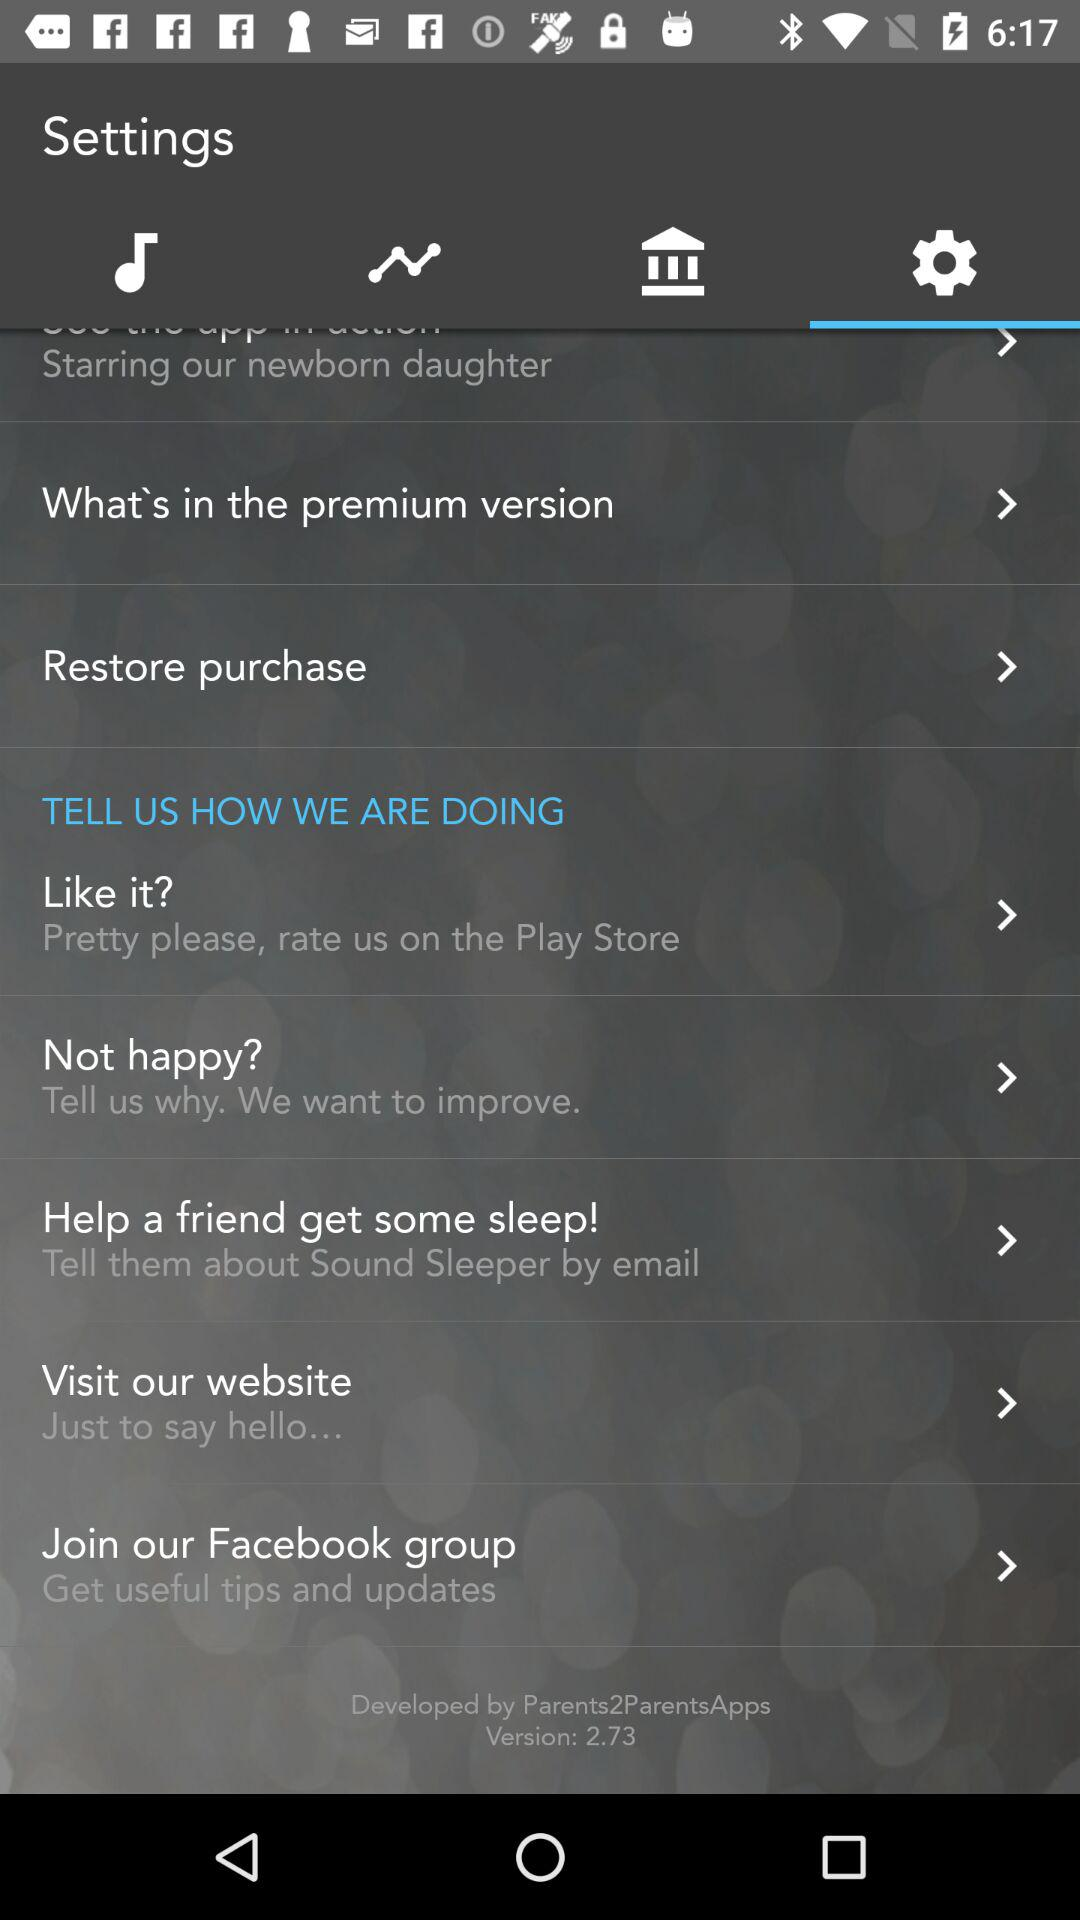What is the name of the developer? The name of the developer is Parents2ParentsApps. 